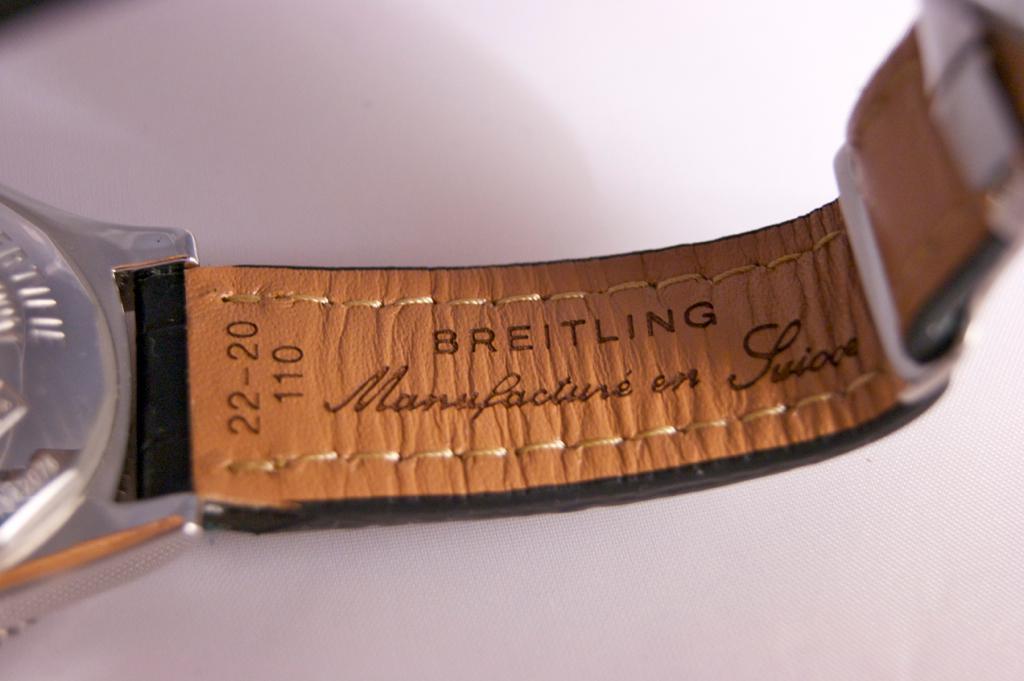What company made the band?
Your answer should be very brief. Breitling. What is the name of the watch?
Your answer should be very brief. Breitling. 